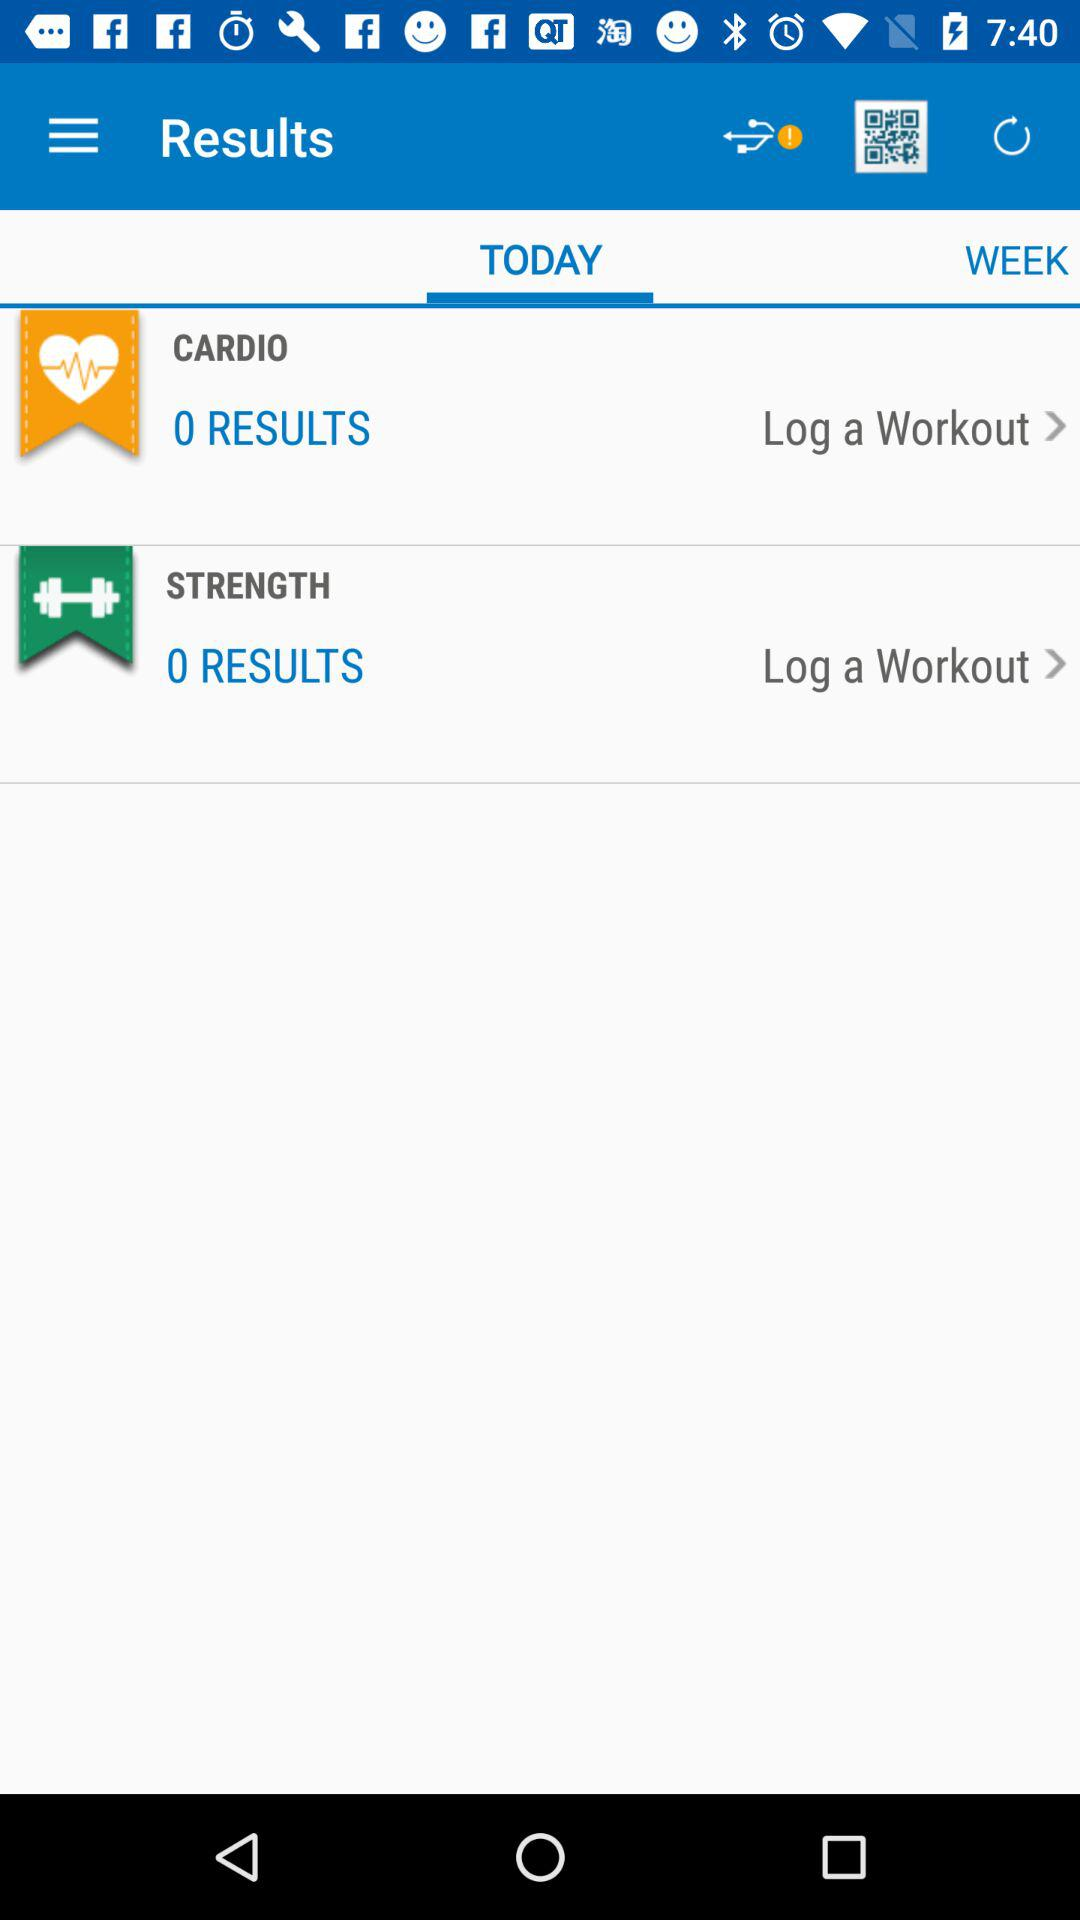What is the number of results for the cardio workout? The number of results is 0. 